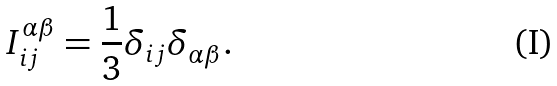<formula> <loc_0><loc_0><loc_500><loc_500>I _ { i j } ^ { \alpha \beta } = \frac { 1 } { 3 } \delta _ { i j } \delta _ { \alpha \beta } .</formula> 